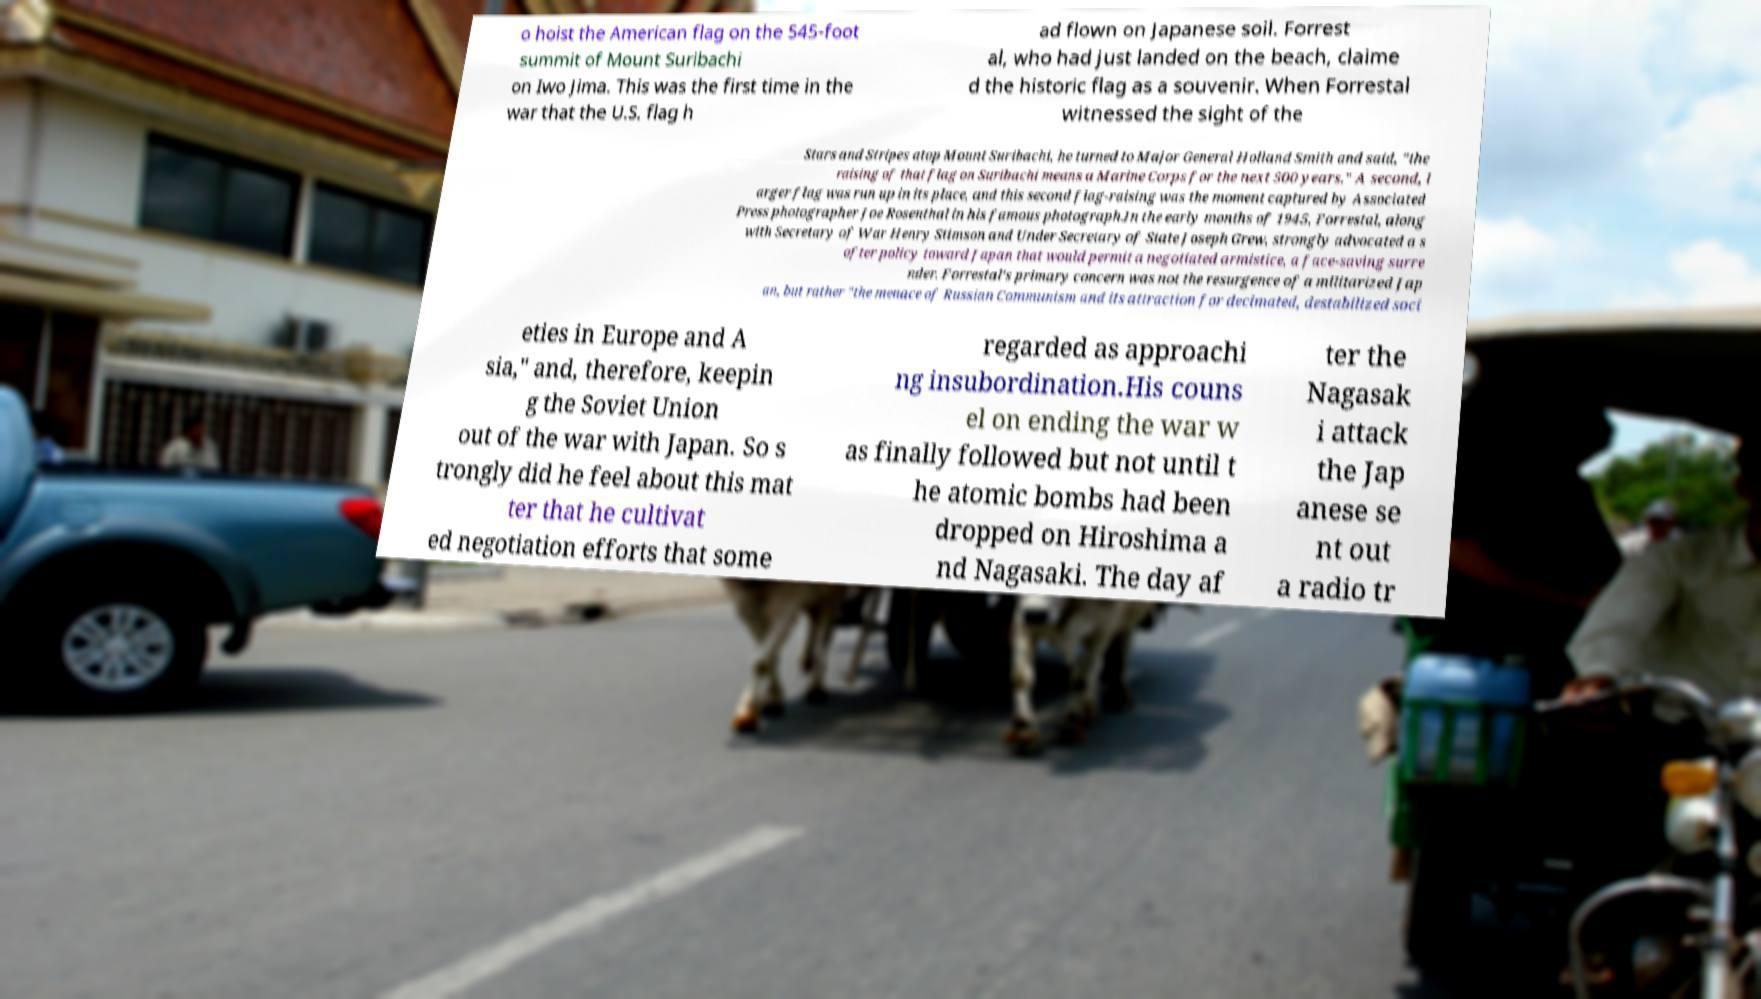Could you assist in decoding the text presented in this image and type it out clearly? o hoist the American flag on the 545-foot summit of Mount Suribachi on Iwo Jima. This was the first time in the war that the U.S. flag h ad flown on Japanese soil. Forrest al, who had just landed on the beach, claime d the historic flag as a souvenir. When Forrestal witnessed the sight of the Stars and Stripes atop Mount Suribachi, he turned to Major General Holland Smith and said, "the raising of that flag on Suribachi means a Marine Corps for the next 500 years." A second, l arger flag was run up in its place, and this second flag-raising was the moment captured by Associated Press photographer Joe Rosenthal in his famous photograph.In the early months of 1945, Forrestal, along with Secretary of War Henry Stimson and Under Secretary of State Joseph Grew, strongly advocated a s ofter policy toward Japan that would permit a negotiated armistice, a face-saving surre nder. Forrestal's primary concern was not the resurgence of a militarized Jap an, but rather "the menace of Russian Communism and its attraction for decimated, destabilized soci eties in Europe and A sia," and, therefore, keepin g the Soviet Union out of the war with Japan. So s trongly did he feel about this mat ter that he cultivat ed negotiation efforts that some regarded as approachi ng insubordination.His couns el on ending the war w as finally followed but not until t he atomic bombs had been dropped on Hiroshima a nd Nagasaki. The day af ter the Nagasak i attack the Jap anese se nt out a radio tr 